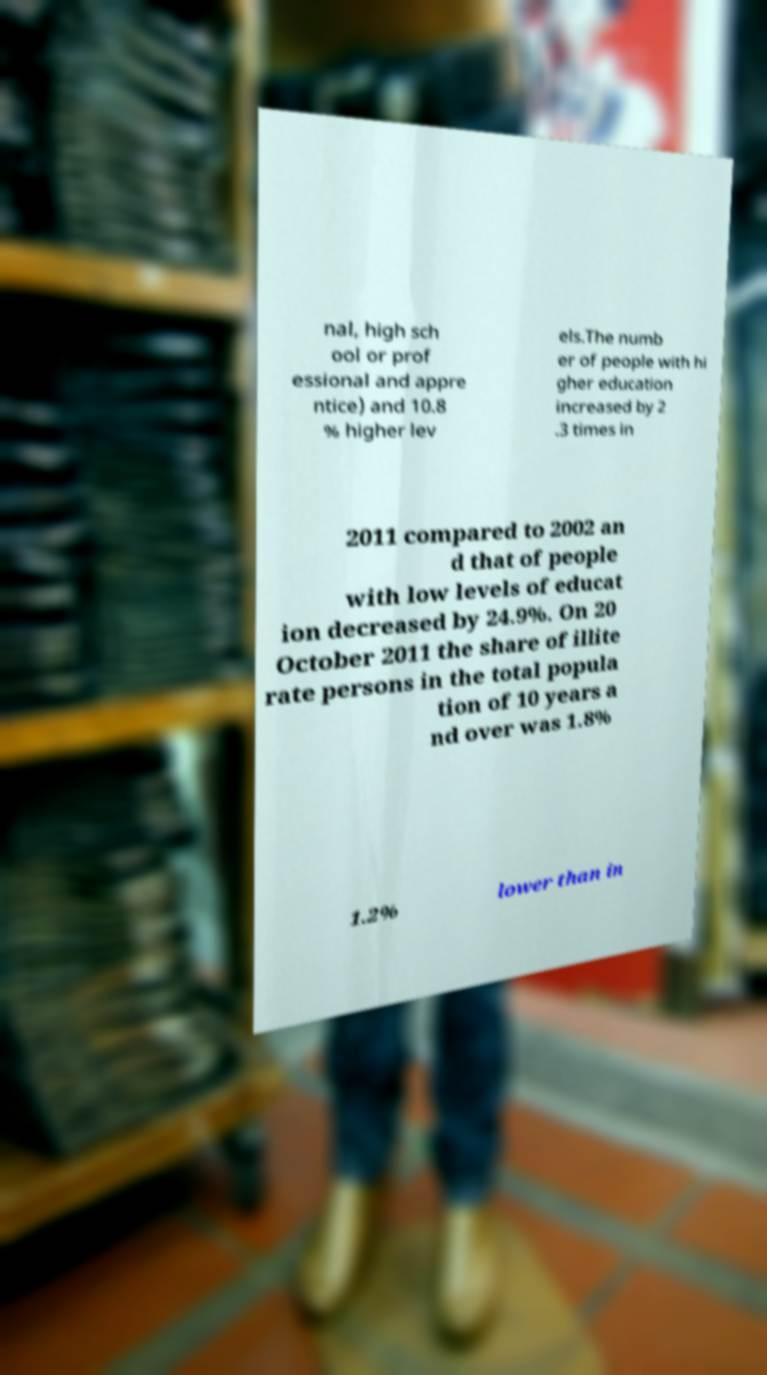What messages or text are displayed in this image? I need them in a readable, typed format. nal, high sch ool or prof essional and appre ntice) and 10.8 % higher lev els.The numb er of people with hi gher education increased by 2 .3 times in 2011 compared to 2002 an d that of people with low levels of educat ion decreased by 24.9%. On 20 October 2011 the share of illite rate persons in the total popula tion of 10 years a nd over was 1.8% 1.2% lower than in 